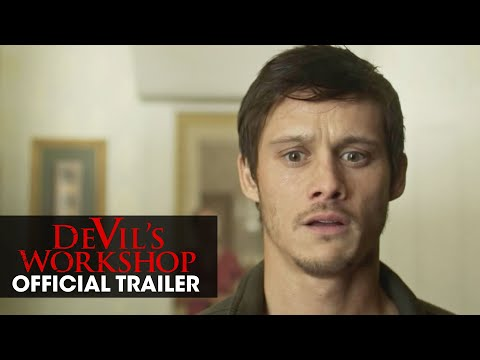Discuss the significance of the red overlay text in the context of this image. The red overlay text 'Devil's Workshop OFFICIAL TRAILER' is significant as it immediately identifies the image as part of a promotional piece for a movie, setting expectations for the audience about the type of content (a thriller or horror film) they might encounter. It also creates a sense of urgency and attention. How does the actor's attire contribute to the overall mood of this movie trailer? The actor's simple gray t-shirt is understated, which keeps the focus firmly on his facial expressions and the emotional weight of the scene. This choice of attire supports the film's likely theme of everyday realism, making the character's extraordinary circumstances more relatable and impactful. 